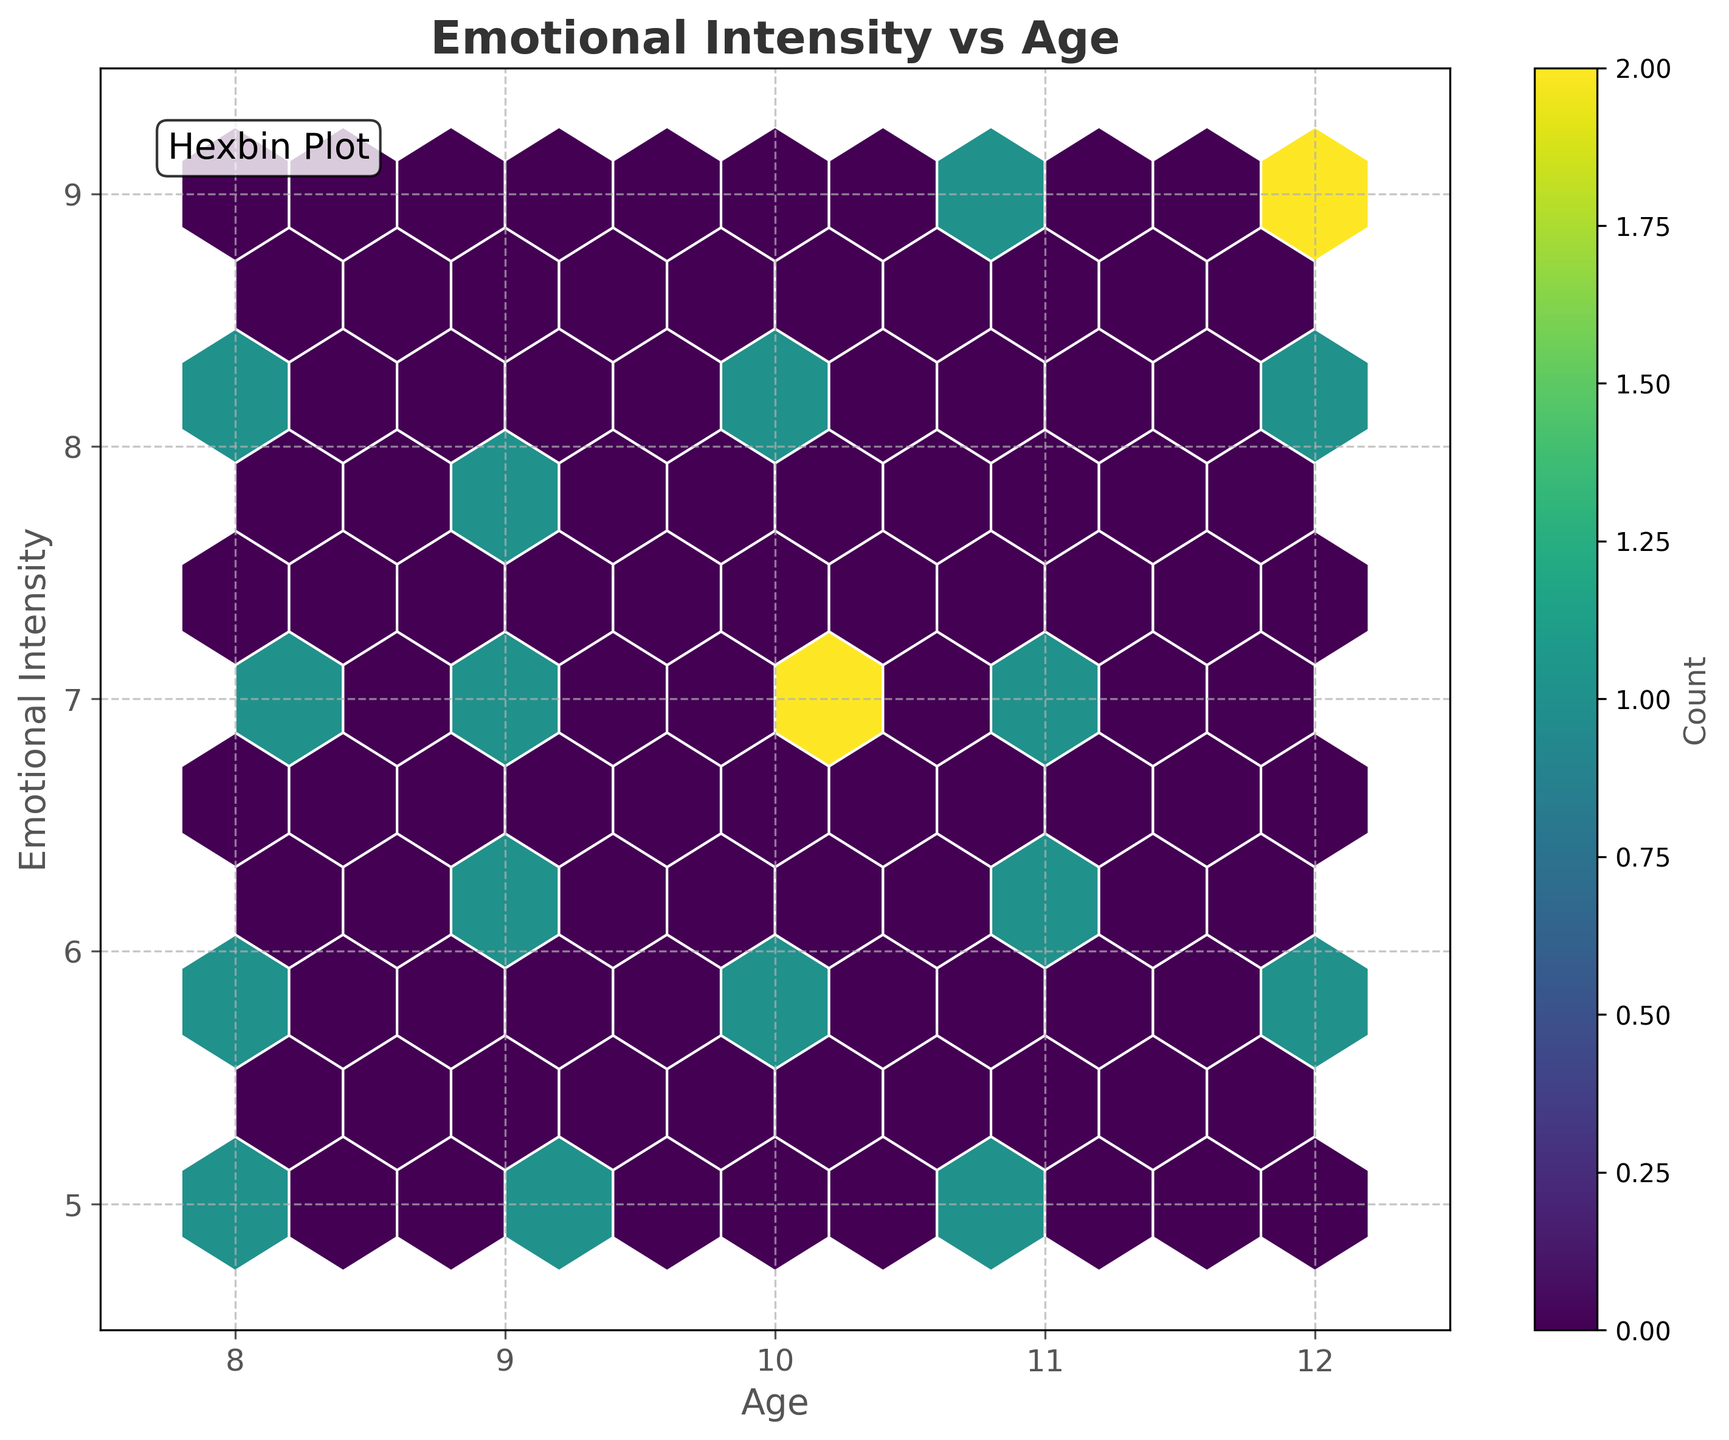What ages are included in the hexbin plot? The x-axis of the hexbin plot is labeled 'Age', and the x-axis range goes from 7.5 to 12.5, which includes the ages between 8 and 12.
Answer: Ages from 8 to 12 What is the range of Emotional Intensity displayed on the plot? The y-axis of the hexbin plot is labeled 'Emotional Intensity', and the y-axis range goes from 4.5 to 9.5, encompassing Emotional Intensity values between 5 and 9.
Answer: Intensity from 5 to 9 Where do you see the highest concentration of data points? The hexbin plot uses a color scale to represent data density. The areas with the darkest color indicate the highest concentration of data points.
Answer: Darkest hexagons What does the color bar represent in the plot? The color bar, labeled 'Count', shows how the colors correspond to the number of data points within each hexbin cell.
Answer: Count of data points How does Emotional Intensity vary with age among young readers? By observing the density and color of hexagons along the 'Age' and 'Emotional Intensity' axes, one can see which ages correspond to higher or lower emotional intensities.
Answer: Varied densities by age Is there any age group that consistently shows high emotional intensity? By scanning the vertical range at each age along the x-axis, identify if any specific age clusters show dark (high-density) hexagons at higher emotional intensities.
Answer: Ages 10 and 12 Which gender is more prominently represented in higher emotional intensities? Since the plot only shows aggregate data without individual markers for gender, we can’t directly deduce gender information from the visual representation alone.
Answer: Not discernible What age shows the lowest variation in Emotional Intensity? Look for any age where the hexbin cells are confined to a narrow vertical band, indicating less variation in Emotional Intensity values.
Answer: Age 11 How many data clusters are evident in the plot? Visually identify the separate groups or clusters of densely populated hexagons on the plot.
Answer: Two to three At what age is the Emotional Intensity most diverse? Determine the age range where hexbin cells spread vertically across the widest span of Emotional Intensity values.
Answer: Age 10 